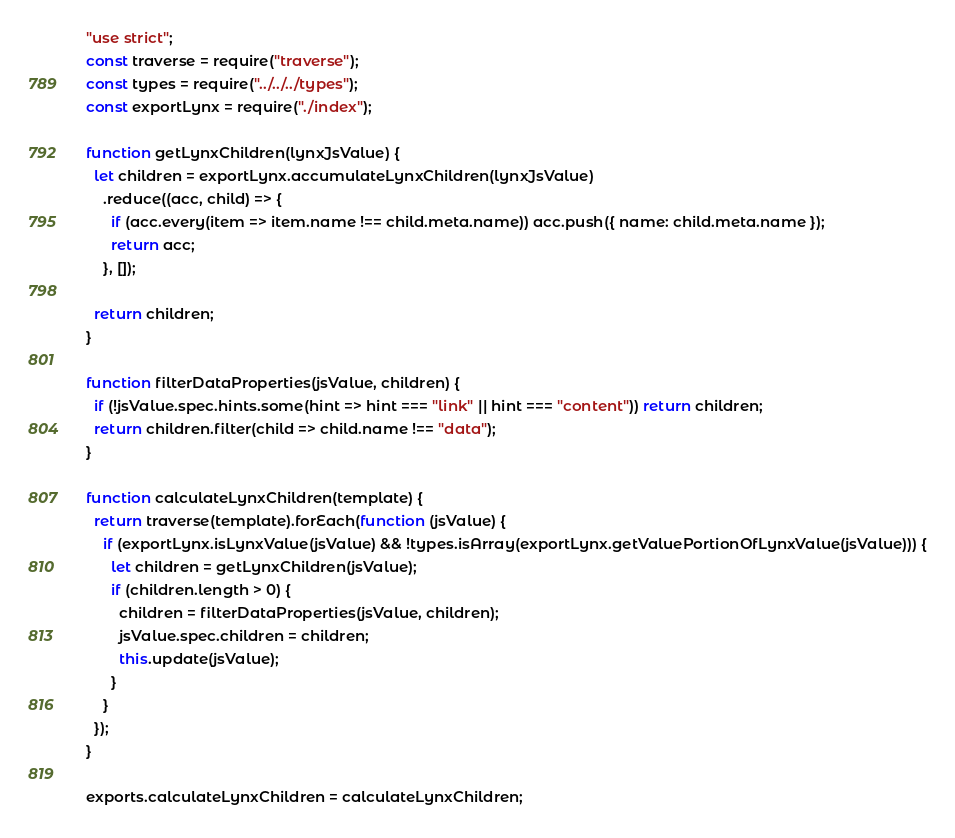<code> <loc_0><loc_0><loc_500><loc_500><_JavaScript_>"use strict";
const traverse = require("traverse");
const types = require("../../../types");
const exportLynx = require("./index");

function getLynxChildren(lynxJsValue) {
  let children = exportLynx.accumulateLynxChildren(lynxJsValue)
    .reduce((acc, child) => {
      if (acc.every(item => item.name !== child.meta.name)) acc.push({ name: child.meta.name });
      return acc;
    }, []);

  return children;
}

function filterDataProperties(jsValue, children) {
  if (!jsValue.spec.hints.some(hint => hint === "link" || hint === "content")) return children;
  return children.filter(child => child.name !== "data");
}

function calculateLynxChildren(template) {
  return traverse(template).forEach(function (jsValue) {
    if (exportLynx.isLynxValue(jsValue) && !types.isArray(exportLynx.getValuePortionOfLynxValue(jsValue))) {
      let children = getLynxChildren(jsValue);
      if (children.length > 0) {
        children = filterDataProperties(jsValue, children);
        jsValue.spec.children = children;
        this.update(jsValue);
      }
    }
  });
}

exports.calculateLynxChildren = calculateLynxChildren;
</code> 